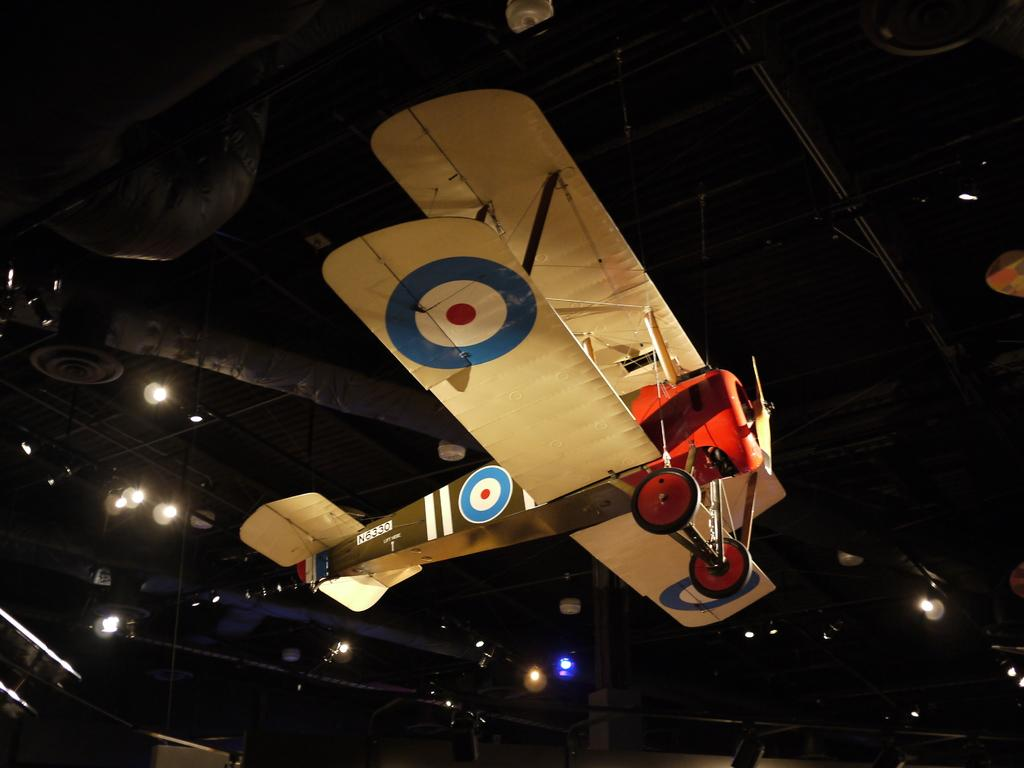What type of toy is hanging in the image? There is a toy aircraft hanging in the image. What part of a building can be seen in the image? The roof is visible in the image. What is the source of light on the roof? There is some light on the roof. What structures are present on the roof? There are rods on the roof. What is attached to the rods on the roof? There are objects attached to the roof. What type of wilderness can be seen in the image? There is no wilderness present in the image; it features a toy aircraft hanging and a roof with rods and objects attached. What color is the sky in the image? The sky is not visible in the image; only the roof and its components are shown. 